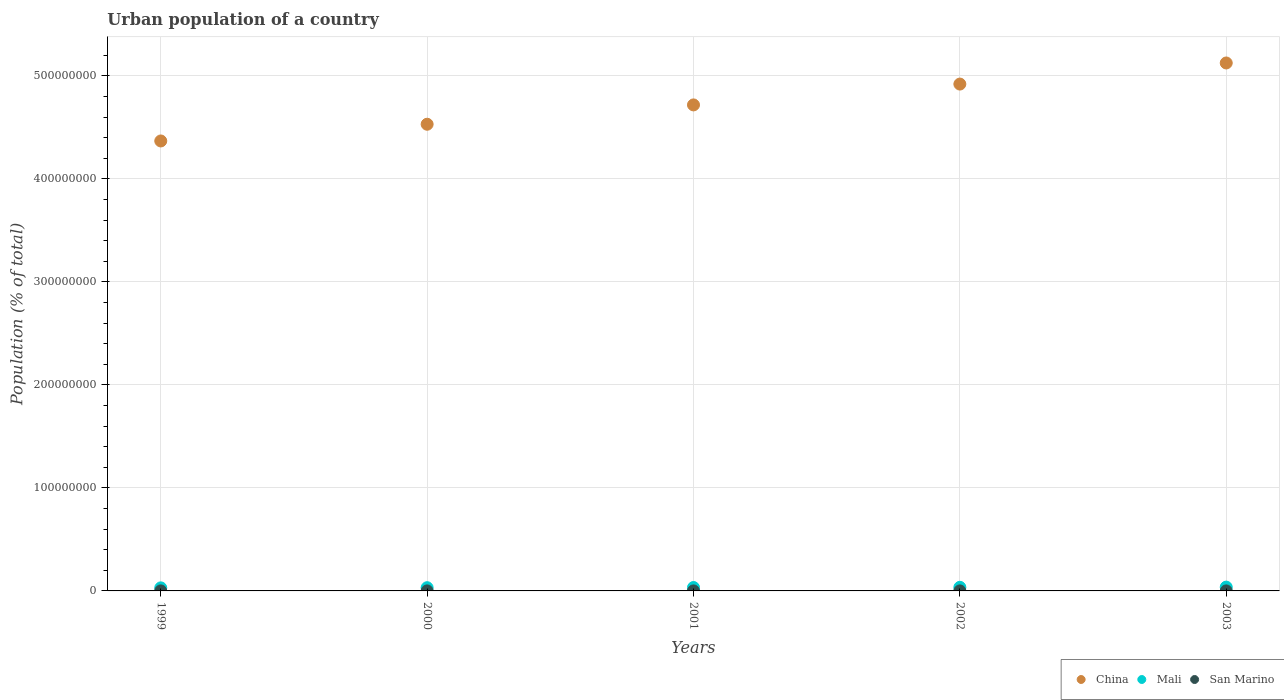How many different coloured dotlines are there?
Provide a short and direct response. 3. Is the number of dotlines equal to the number of legend labels?
Offer a very short reply. Yes. What is the urban population in China in 1999?
Keep it short and to the point. 4.37e+08. Across all years, what is the maximum urban population in Mali?
Give a very brief answer. 3.69e+06. Across all years, what is the minimum urban population in China?
Ensure brevity in your answer.  4.37e+08. In which year was the urban population in Mali maximum?
Offer a terse response. 2003. What is the total urban population in Mali in the graph?
Offer a very short reply. 1.66e+07. What is the difference between the urban population in Mali in 2000 and that in 2003?
Give a very brief answer. -5.60e+05. What is the difference between the urban population in San Marino in 2003 and the urban population in Mali in 2001?
Ensure brevity in your answer.  -3.28e+06. What is the average urban population in China per year?
Offer a very short reply. 4.73e+08. In the year 2003, what is the difference between the urban population in San Marino and urban population in Mali?
Keep it short and to the point. -3.67e+06. What is the ratio of the urban population in San Marino in 2002 to that in 2003?
Your answer should be compact. 0.99. Is the urban population in San Marino in 1999 less than that in 2000?
Your answer should be compact. Yes. Is the difference between the urban population in San Marino in 2000 and 2002 greater than the difference between the urban population in Mali in 2000 and 2002?
Make the answer very short. Yes. What is the difference between the highest and the second highest urban population in San Marino?
Provide a short and direct response. 370. What is the difference between the highest and the lowest urban population in China?
Offer a very short reply. 7.57e+07. Is the urban population in China strictly less than the urban population in San Marino over the years?
Your response must be concise. No. How many years are there in the graph?
Offer a very short reply. 5. Does the graph contain any zero values?
Provide a succinct answer. No. Does the graph contain grids?
Your response must be concise. Yes. What is the title of the graph?
Offer a terse response. Urban population of a country. What is the label or title of the Y-axis?
Your answer should be compact. Population (% of total). What is the Population (% of total) of China in 1999?
Your answer should be compact. 4.37e+08. What is the Population (% of total) in Mali in 1999?
Provide a succinct answer. 2.97e+06. What is the Population (% of total) in San Marino in 1999?
Your response must be concise. 2.52e+04. What is the Population (% of total) in China in 2000?
Keep it short and to the point. 4.53e+08. What is the Population (% of total) in Mali in 2000?
Your answer should be very brief. 3.13e+06. What is the Population (% of total) in San Marino in 2000?
Your answer should be compact. 2.56e+04. What is the Population (% of total) in China in 2001?
Offer a very short reply. 4.72e+08. What is the Population (% of total) of Mali in 2001?
Offer a very short reply. 3.31e+06. What is the Population (% of total) in San Marino in 2001?
Your answer should be very brief. 2.60e+04. What is the Population (% of total) in China in 2002?
Keep it short and to the point. 4.92e+08. What is the Population (% of total) in Mali in 2002?
Give a very brief answer. 3.49e+06. What is the Population (% of total) in San Marino in 2002?
Ensure brevity in your answer.  2.64e+04. What is the Population (% of total) in China in 2003?
Your answer should be very brief. 5.12e+08. What is the Population (% of total) of Mali in 2003?
Give a very brief answer. 3.69e+06. What is the Population (% of total) in San Marino in 2003?
Offer a very short reply. 2.68e+04. Across all years, what is the maximum Population (% of total) of China?
Offer a very short reply. 5.12e+08. Across all years, what is the maximum Population (% of total) in Mali?
Your answer should be very brief. 3.69e+06. Across all years, what is the maximum Population (% of total) of San Marino?
Give a very brief answer. 2.68e+04. Across all years, what is the minimum Population (% of total) in China?
Your response must be concise. 4.37e+08. Across all years, what is the minimum Population (% of total) in Mali?
Provide a short and direct response. 2.97e+06. Across all years, what is the minimum Population (% of total) in San Marino?
Provide a succinct answer. 2.52e+04. What is the total Population (% of total) of China in the graph?
Provide a succinct answer. 2.37e+09. What is the total Population (% of total) of Mali in the graph?
Provide a short and direct response. 1.66e+07. What is the total Population (% of total) of San Marino in the graph?
Keep it short and to the point. 1.30e+05. What is the difference between the Population (% of total) of China in 1999 and that in 2000?
Give a very brief answer. -1.62e+07. What is the difference between the Population (% of total) of Mali in 1999 and that in 2000?
Ensure brevity in your answer.  -1.64e+05. What is the difference between the Population (% of total) in San Marino in 1999 and that in 2000?
Offer a very short reply. -390. What is the difference between the Population (% of total) in China in 1999 and that in 2001?
Keep it short and to the point. -3.50e+07. What is the difference between the Population (% of total) of Mali in 1999 and that in 2001?
Provide a succinct answer. -3.39e+05. What is the difference between the Population (% of total) in San Marino in 1999 and that in 2001?
Your answer should be compact. -804. What is the difference between the Population (% of total) in China in 1999 and that in 2002?
Your answer should be very brief. -5.52e+07. What is the difference between the Population (% of total) of Mali in 1999 and that in 2002?
Offer a very short reply. -5.26e+05. What is the difference between the Population (% of total) of San Marino in 1999 and that in 2002?
Ensure brevity in your answer.  -1201. What is the difference between the Population (% of total) of China in 1999 and that in 2003?
Keep it short and to the point. -7.57e+07. What is the difference between the Population (% of total) in Mali in 1999 and that in 2003?
Provide a succinct answer. -7.25e+05. What is the difference between the Population (% of total) of San Marino in 1999 and that in 2003?
Ensure brevity in your answer.  -1571. What is the difference between the Population (% of total) in China in 2000 and that in 2001?
Offer a very short reply. -1.88e+07. What is the difference between the Population (% of total) of Mali in 2000 and that in 2001?
Make the answer very short. -1.75e+05. What is the difference between the Population (% of total) in San Marino in 2000 and that in 2001?
Make the answer very short. -414. What is the difference between the Population (% of total) of China in 2000 and that in 2002?
Keep it short and to the point. -3.90e+07. What is the difference between the Population (% of total) of Mali in 2000 and that in 2002?
Give a very brief answer. -3.62e+05. What is the difference between the Population (% of total) in San Marino in 2000 and that in 2002?
Ensure brevity in your answer.  -811. What is the difference between the Population (% of total) in China in 2000 and that in 2003?
Provide a short and direct response. -5.95e+07. What is the difference between the Population (% of total) in Mali in 2000 and that in 2003?
Keep it short and to the point. -5.60e+05. What is the difference between the Population (% of total) of San Marino in 2000 and that in 2003?
Provide a succinct answer. -1181. What is the difference between the Population (% of total) in China in 2001 and that in 2002?
Make the answer very short. -2.02e+07. What is the difference between the Population (% of total) of Mali in 2001 and that in 2002?
Offer a terse response. -1.87e+05. What is the difference between the Population (% of total) in San Marino in 2001 and that in 2002?
Provide a short and direct response. -397. What is the difference between the Population (% of total) in China in 2001 and that in 2003?
Offer a terse response. -4.07e+07. What is the difference between the Population (% of total) in Mali in 2001 and that in 2003?
Your answer should be compact. -3.85e+05. What is the difference between the Population (% of total) in San Marino in 2001 and that in 2003?
Make the answer very short. -767. What is the difference between the Population (% of total) in China in 2002 and that in 2003?
Offer a terse response. -2.05e+07. What is the difference between the Population (% of total) of Mali in 2002 and that in 2003?
Offer a very short reply. -1.99e+05. What is the difference between the Population (% of total) in San Marino in 2002 and that in 2003?
Ensure brevity in your answer.  -370. What is the difference between the Population (% of total) of China in 1999 and the Population (% of total) of Mali in 2000?
Provide a short and direct response. 4.34e+08. What is the difference between the Population (% of total) of China in 1999 and the Population (% of total) of San Marino in 2000?
Your response must be concise. 4.37e+08. What is the difference between the Population (% of total) of Mali in 1999 and the Population (% of total) of San Marino in 2000?
Make the answer very short. 2.94e+06. What is the difference between the Population (% of total) in China in 1999 and the Population (% of total) in Mali in 2001?
Your answer should be very brief. 4.33e+08. What is the difference between the Population (% of total) of China in 1999 and the Population (% of total) of San Marino in 2001?
Provide a short and direct response. 4.37e+08. What is the difference between the Population (% of total) of Mali in 1999 and the Population (% of total) of San Marino in 2001?
Provide a short and direct response. 2.94e+06. What is the difference between the Population (% of total) in China in 1999 and the Population (% of total) in Mali in 2002?
Your answer should be compact. 4.33e+08. What is the difference between the Population (% of total) of China in 1999 and the Population (% of total) of San Marino in 2002?
Offer a terse response. 4.37e+08. What is the difference between the Population (% of total) in Mali in 1999 and the Population (% of total) in San Marino in 2002?
Give a very brief answer. 2.94e+06. What is the difference between the Population (% of total) in China in 1999 and the Population (% of total) in Mali in 2003?
Offer a terse response. 4.33e+08. What is the difference between the Population (% of total) of China in 1999 and the Population (% of total) of San Marino in 2003?
Offer a terse response. 4.37e+08. What is the difference between the Population (% of total) of Mali in 1999 and the Population (% of total) of San Marino in 2003?
Provide a short and direct response. 2.94e+06. What is the difference between the Population (% of total) of China in 2000 and the Population (% of total) of Mali in 2001?
Provide a short and direct response. 4.50e+08. What is the difference between the Population (% of total) of China in 2000 and the Population (% of total) of San Marino in 2001?
Make the answer very short. 4.53e+08. What is the difference between the Population (% of total) in Mali in 2000 and the Population (% of total) in San Marino in 2001?
Provide a short and direct response. 3.11e+06. What is the difference between the Population (% of total) in China in 2000 and the Population (% of total) in Mali in 2002?
Give a very brief answer. 4.50e+08. What is the difference between the Population (% of total) in China in 2000 and the Population (% of total) in San Marino in 2002?
Your answer should be compact. 4.53e+08. What is the difference between the Population (% of total) of Mali in 2000 and the Population (% of total) of San Marino in 2002?
Keep it short and to the point. 3.11e+06. What is the difference between the Population (% of total) of China in 2000 and the Population (% of total) of Mali in 2003?
Your answer should be compact. 4.49e+08. What is the difference between the Population (% of total) of China in 2000 and the Population (% of total) of San Marino in 2003?
Make the answer very short. 4.53e+08. What is the difference between the Population (% of total) of Mali in 2000 and the Population (% of total) of San Marino in 2003?
Keep it short and to the point. 3.11e+06. What is the difference between the Population (% of total) of China in 2001 and the Population (% of total) of Mali in 2002?
Offer a very short reply. 4.68e+08. What is the difference between the Population (% of total) of China in 2001 and the Population (% of total) of San Marino in 2002?
Your answer should be very brief. 4.72e+08. What is the difference between the Population (% of total) of Mali in 2001 and the Population (% of total) of San Marino in 2002?
Your response must be concise. 3.28e+06. What is the difference between the Population (% of total) of China in 2001 and the Population (% of total) of Mali in 2003?
Your answer should be compact. 4.68e+08. What is the difference between the Population (% of total) of China in 2001 and the Population (% of total) of San Marino in 2003?
Provide a short and direct response. 4.72e+08. What is the difference between the Population (% of total) of Mali in 2001 and the Population (% of total) of San Marino in 2003?
Give a very brief answer. 3.28e+06. What is the difference between the Population (% of total) of China in 2002 and the Population (% of total) of Mali in 2003?
Your answer should be very brief. 4.88e+08. What is the difference between the Population (% of total) in China in 2002 and the Population (% of total) in San Marino in 2003?
Offer a very short reply. 4.92e+08. What is the difference between the Population (% of total) of Mali in 2002 and the Population (% of total) of San Marino in 2003?
Your answer should be very brief. 3.47e+06. What is the average Population (% of total) of China per year?
Offer a terse response. 4.73e+08. What is the average Population (% of total) of Mali per year?
Make the answer very short. 3.32e+06. What is the average Population (% of total) in San Marino per year?
Keep it short and to the point. 2.60e+04. In the year 1999, what is the difference between the Population (% of total) in China and Population (% of total) in Mali?
Offer a terse response. 4.34e+08. In the year 1999, what is the difference between the Population (% of total) of China and Population (% of total) of San Marino?
Provide a short and direct response. 4.37e+08. In the year 1999, what is the difference between the Population (% of total) of Mali and Population (% of total) of San Marino?
Provide a succinct answer. 2.94e+06. In the year 2000, what is the difference between the Population (% of total) of China and Population (% of total) of Mali?
Make the answer very short. 4.50e+08. In the year 2000, what is the difference between the Population (% of total) of China and Population (% of total) of San Marino?
Provide a succinct answer. 4.53e+08. In the year 2000, what is the difference between the Population (% of total) of Mali and Population (% of total) of San Marino?
Your answer should be very brief. 3.11e+06. In the year 2001, what is the difference between the Population (% of total) of China and Population (% of total) of Mali?
Offer a terse response. 4.68e+08. In the year 2001, what is the difference between the Population (% of total) in China and Population (% of total) in San Marino?
Ensure brevity in your answer.  4.72e+08. In the year 2001, what is the difference between the Population (% of total) of Mali and Population (% of total) of San Marino?
Offer a terse response. 3.28e+06. In the year 2002, what is the difference between the Population (% of total) in China and Population (% of total) in Mali?
Keep it short and to the point. 4.88e+08. In the year 2002, what is the difference between the Population (% of total) of China and Population (% of total) of San Marino?
Your answer should be compact. 4.92e+08. In the year 2002, what is the difference between the Population (% of total) of Mali and Population (% of total) of San Marino?
Your answer should be very brief. 3.47e+06. In the year 2003, what is the difference between the Population (% of total) in China and Population (% of total) in Mali?
Your answer should be compact. 5.09e+08. In the year 2003, what is the difference between the Population (% of total) in China and Population (% of total) in San Marino?
Your answer should be very brief. 5.12e+08. In the year 2003, what is the difference between the Population (% of total) of Mali and Population (% of total) of San Marino?
Ensure brevity in your answer.  3.67e+06. What is the ratio of the Population (% of total) of China in 1999 to that in 2000?
Offer a terse response. 0.96. What is the ratio of the Population (% of total) of Mali in 1999 to that in 2000?
Offer a terse response. 0.95. What is the ratio of the Population (% of total) in China in 1999 to that in 2001?
Ensure brevity in your answer.  0.93. What is the ratio of the Population (% of total) in Mali in 1999 to that in 2001?
Provide a succinct answer. 0.9. What is the ratio of the Population (% of total) in San Marino in 1999 to that in 2001?
Your answer should be compact. 0.97. What is the ratio of the Population (% of total) in China in 1999 to that in 2002?
Your answer should be compact. 0.89. What is the ratio of the Population (% of total) of Mali in 1999 to that in 2002?
Your answer should be very brief. 0.85. What is the ratio of the Population (% of total) in San Marino in 1999 to that in 2002?
Keep it short and to the point. 0.95. What is the ratio of the Population (% of total) of China in 1999 to that in 2003?
Offer a terse response. 0.85. What is the ratio of the Population (% of total) of Mali in 1999 to that in 2003?
Offer a terse response. 0.8. What is the ratio of the Population (% of total) in San Marino in 1999 to that in 2003?
Make the answer very short. 0.94. What is the ratio of the Population (% of total) of China in 2000 to that in 2001?
Your answer should be very brief. 0.96. What is the ratio of the Population (% of total) of Mali in 2000 to that in 2001?
Offer a very short reply. 0.95. What is the ratio of the Population (% of total) of San Marino in 2000 to that in 2001?
Give a very brief answer. 0.98. What is the ratio of the Population (% of total) in China in 2000 to that in 2002?
Your response must be concise. 0.92. What is the ratio of the Population (% of total) in Mali in 2000 to that in 2002?
Your answer should be compact. 0.9. What is the ratio of the Population (% of total) of San Marino in 2000 to that in 2002?
Keep it short and to the point. 0.97. What is the ratio of the Population (% of total) in China in 2000 to that in 2003?
Ensure brevity in your answer.  0.88. What is the ratio of the Population (% of total) in Mali in 2000 to that in 2003?
Provide a succinct answer. 0.85. What is the ratio of the Population (% of total) in San Marino in 2000 to that in 2003?
Your answer should be compact. 0.96. What is the ratio of the Population (% of total) in China in 2001 to that in 2002?
Offer a very short reply. 0.96. What is the ratio of the Population (% of total) of Mali in 2001 to that in 2002?
Provide a succinct answer. 0.95. What is the ratio of the Population (% of total) of China in 2001 to that in 2003?
Keep it short and to the point. 0.92. What is the ratio of the Population (% of total) in Mali in 2001 to that in 2003?
Provide a succinct answer. 0.9. What is the ratio of the Population (% of total) of San Marino in 2001 to that in 2003?
Make the answer very short. 0.97. What is the ratio of the Population (% of total) in China in 2002 to that in 2003?
Your answer should be compact. 0.96. What is the ratio of the Population (% of total) of Mali in 2002 to that in 2003?
Your answer should be very brief. 0.95. What is the ratio of the Population (% of total) of San Marino in 2002 to that in 2003?
Give a very brief answer. 0.99. What is the difference between the highest and the second highest Population (% of total) of China?
Provide a short and direct response. 2.05e+07. What is the difference between the highest and the second highest Population (% of total) in Mali?
Make the answer very short. 1.99e+05. What is the difference between the highest and the second highest Population (% of total) in San Marino?
Provide a short and direct response. 370. What is the difference between the highest and the lowest Population (% of total) in China?
Ensure brevity in your answer.  7.57e+07. What is the difference between the highest and the lowest Population (% of total) of Mali?
Give a very brief answer. 7.25e+05. What is the difference between the highest and the lowest Population (% of total) in San Marino?
Provide a short and direct response. 1571. 